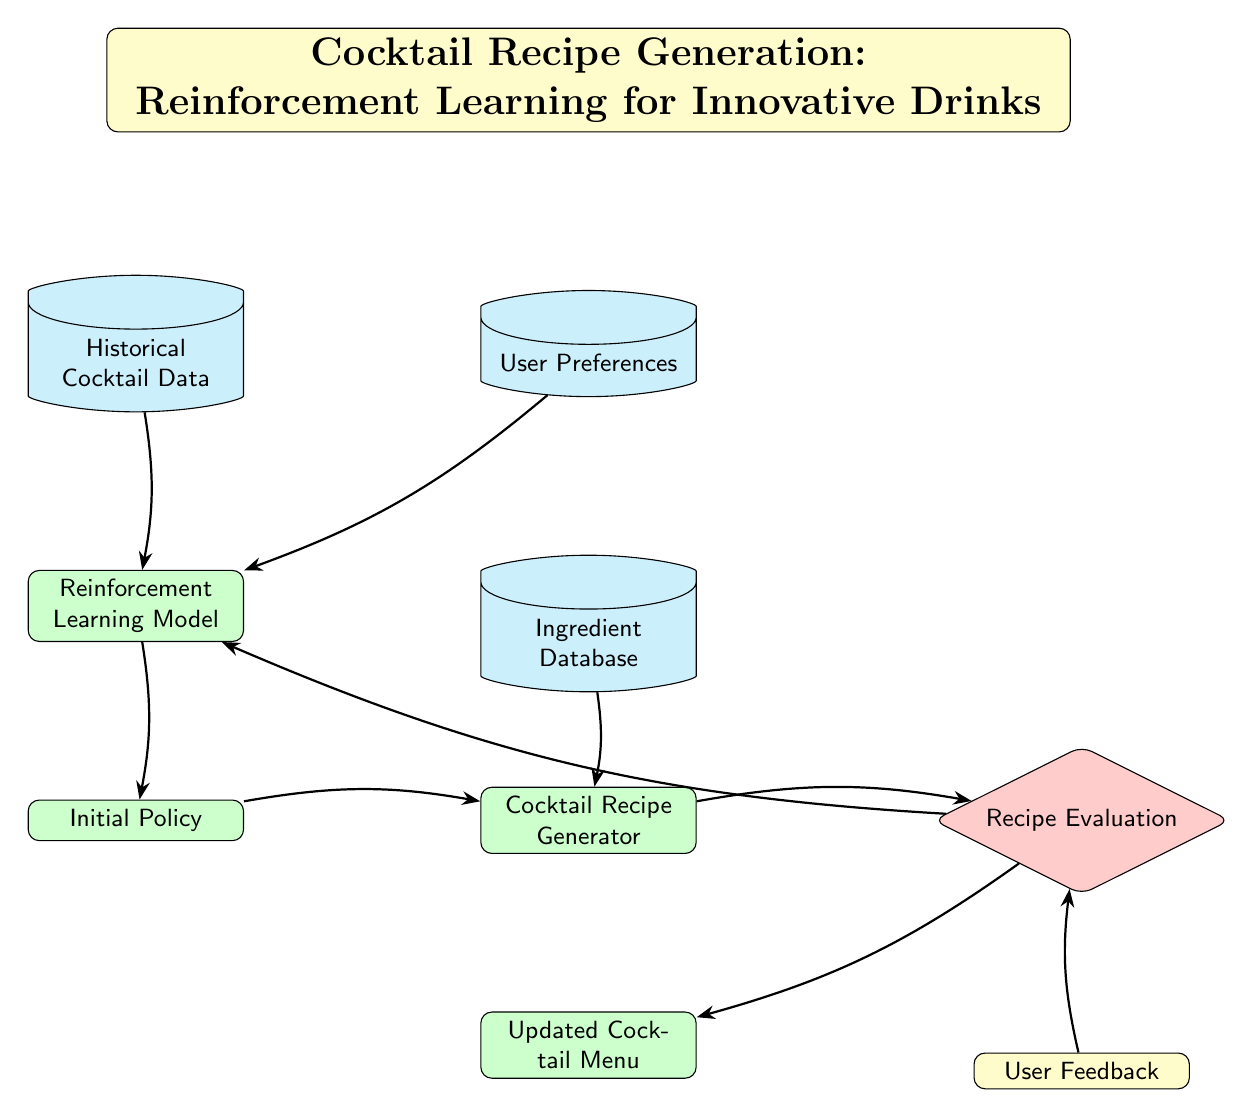What is the title of the diagram? The title is prominently displayed at the top of the diagram, stating "Cocktail Recipe Generation: Reinforcement Learning for Innovative Drinks."
Answer: Cocktail Recipe Generation: Reinforcement Learning for Innovative Drinks How many database nodes are present in the diagram? Counting the shapes in the diagram that represents databases, there are three: Historical Cocktail Data, User Preferences, and Ingredient Database.
Answer: 3 Which process follows the reinforcement learning model? Directly below the reinforcement learning model, there is a node labeled "Initial Policy," making it the immediate successor in the flow of the diagram.
Answer: Initial Policy What type of feedback is used to evaluate the recipes? The diagram suggests "User Feedback" is used for evaluating the generated recipes, indicating that user interaction is critical in the evaluation process.
Answer: User Feedback What does the cocktail generator rely on as input? The cocktail generator node indicates it directly receives input from the "Initial Policy" node, suggesting that the policy informs how to generate the cocktails.
Answer: Initial Policy Which node is evaluated next after the cocktail generator? After the cocktail generator process, the next node in the flow is labeled "Recipe Evaluation," meaning it assesses the cocktail recipes generated before proceeding further.
Answer: Recipe Evaluation What is the outcome of the recipe evaluation? The outcome of the Recipe Evaluation leads to two subsequent nodes: feedback and updated cocktail menu, showing that evaluation informs both user feedback and the improvement of the cocktail offerings.
Answer: User Feedback and Updated Cocktail Menu What is the purpose of historical cocktail data in the diagram? The Historical Cocktail Data acts as an input to the Reinforcement Learning Model, providing the necessary context and prior examples from which the model can learn and improve.
Answer: Input for Reinforcement Learning Model What does the updated cocktail menu represent? The updated cocktail menu is a process that reflects the changes made following the evaluation of cocktail recipes, indicating that it incorporates feedback and improvements.
Answer: Updated Cocktail Menu 